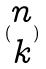Convert formula to latex. <formula><loc_0><loc_0><loc_500><loc_500>( \begin{matrix} n \\ k \end{matrix} )</formula> 